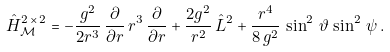<formula> <loc_0><loc_0><loc_500><loc_500>\hat { H } ^ { 2 \, \times \, 2 } _ { \mathcal { M } } = - \frac { g ^ { 2 } } { 2 r ^ { 3 } } \, \frac { \partial } { \partial r } \, r ^ { 3 } \, \frac { \partial } { \partial r } + \frac { 2 g ^ { 2 } } { r ^ { 2 } } \, \hat { L } ^ { 2 } + \frac { r ^ { 4 } } { 8 \, g ^ { 2 } } \, \sin ^ { 2 } \, \vartheta \, \sin ^ { 2 } \, \psi \, .</formula> 